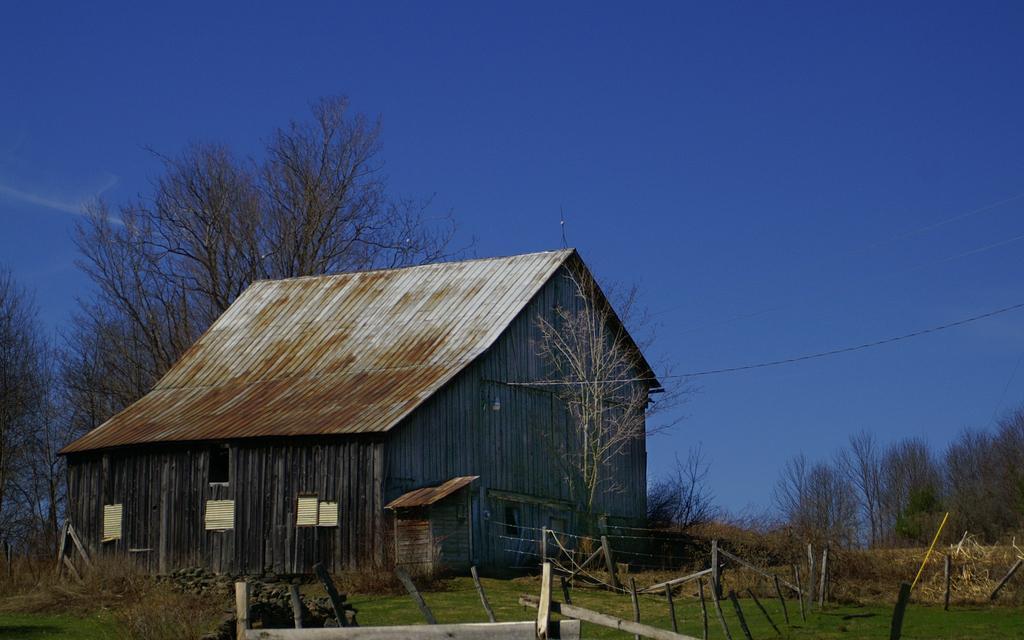Can you describe this image briefly? In this image I can see the house. In-front of the house I can see the fence wire, many wooden poles and trees. In the background I can see few more trees and the blue sky. 